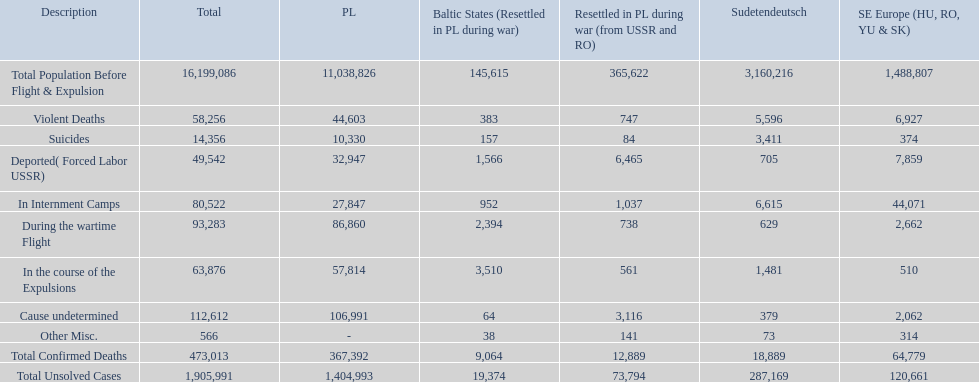What are all of the descriptions? Total Population Before Flight & Expulsion, Violent Deaths, Suicides, Deported( Forced Labor USSR), In Internment Camps, During the wartime Flight, In the course of the Expulsions, Cause undetermined, Other Misc., Total Confirmed Deaths, Total Unsolved Cases. What were their total number of deaths? 16,199,086, 58,256, 14,356, 49,542, 80,522, 93,283, 63,876, 112,612, 566, 473,013, 1,905,991. What about just from violent deaths? 58,256. 